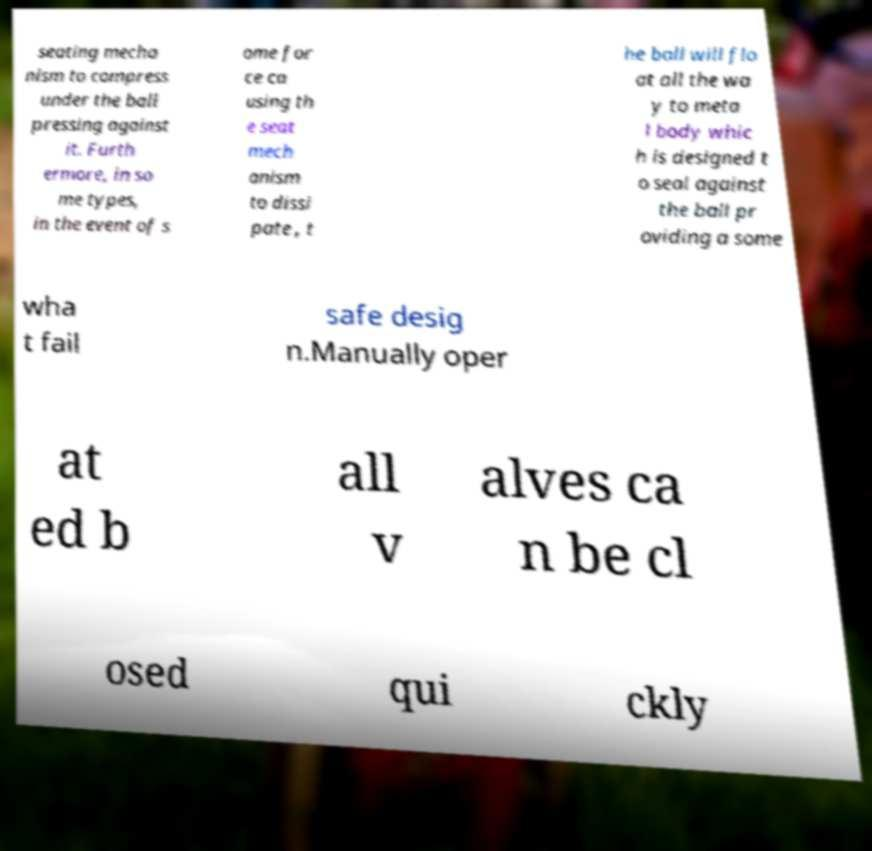There's text embedded in this image that I need extracted. Can you transcribe it verbatim? seating mecha nism to compress under the ball pressing against it. Furth ermore, in so me types, in the event of s ome for ce ca using th e seat mech anism to dissi pate , t he ball will flo at all the wa y to meta l body whic h is designed t o seal against the ball pr oviding a some wha t fail safe desig n.Manually oper at ed b all v alves ca n be cl osed qui ckly 